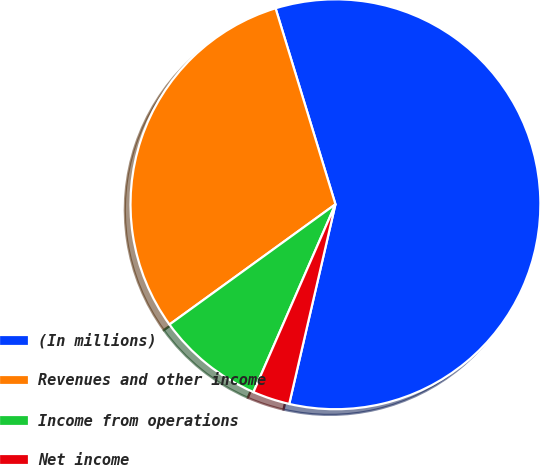Convert chart to OTSL. <chart><loc_0><loc_0><loc_500><loc_500><pie_chart><fcel>(In millions)<fcel>Revenues and other income<fcel>Income from operations<fcel>Net income<nl><fcel>58.34%<fcel>30.26%<fcel>8.47%<fcel>2.93%<nl></chart> 